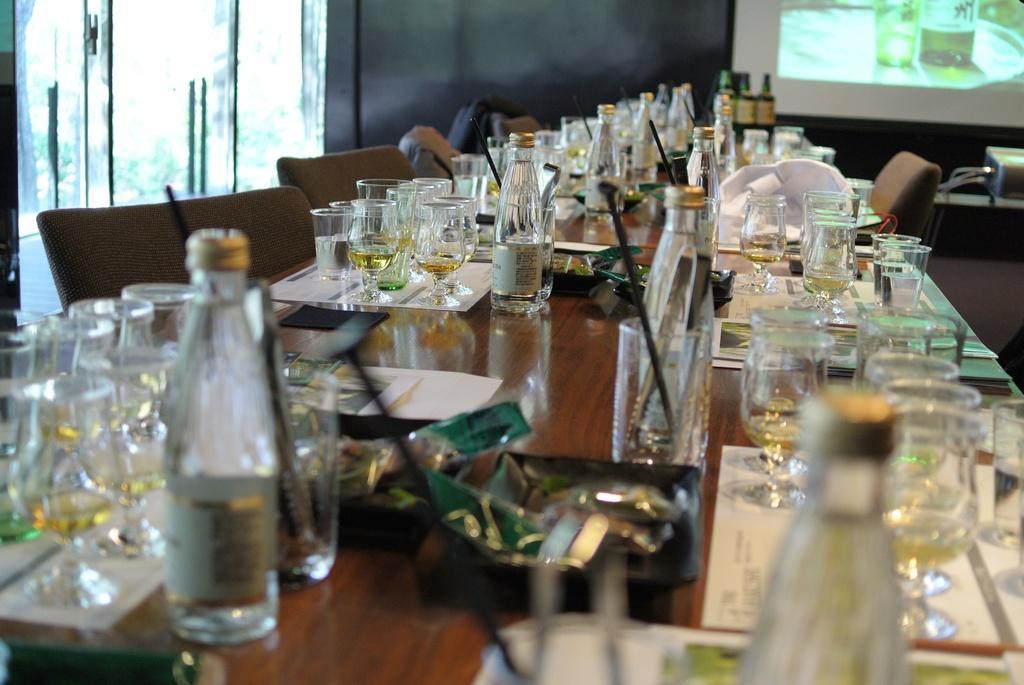How would you summarize this image in a sentence or two? In the picture we can see a table, chairs, and glass doors. On the table we can find group of glasses and bottles, with wine. 